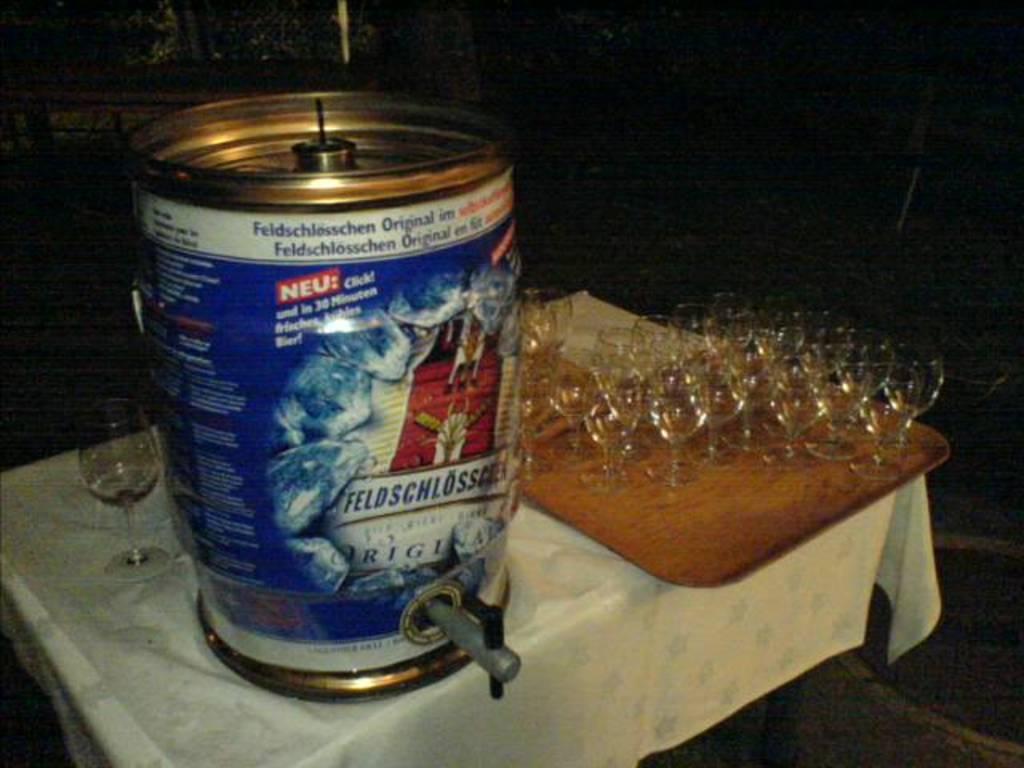In what language is this beer?
Offer a very short reply. German. 